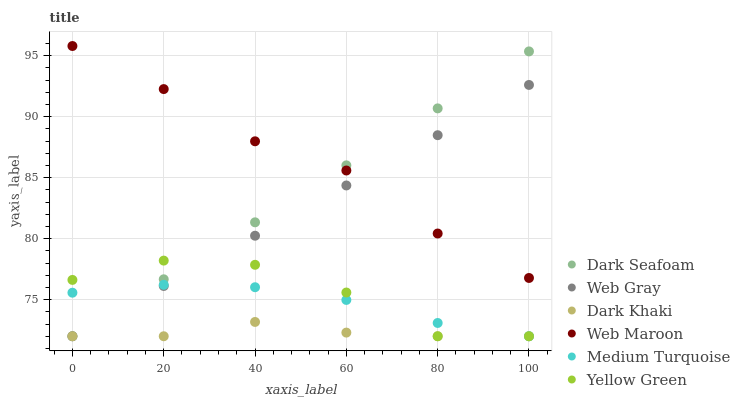Does Dark Khaki have the minimum area under the curve?
Answer yes or no. Yes. Does Web Maroon have the maximum area under the curve?
Answer yes or no. Yes. Does Yellow Green have the minimum area under the curve?
Answer yes or no. No. Does Yellow Green have the maximum area under the curve?
Answer yes or no. No. Is Dark Seafoam the smoothest?
Answer yes or no. Yes. Is Yellow Green the roughest?
Answer yes or no. Yes. Is Web Maroon the smoothest?
Answer yes or no. No. Is Web Maroon the roughest?
Answer yes or no. No. Does Web Gray have the lowest value?
Answer yes or no. Yes. Does Web Maroon have the lowest value?
Answer yes or no. No. Does Web Maroon have the highest value?
Answer yes or no. Yes. Does Yellow Green have the highest value?
Answer yes or no. No. Is Yellow Green less than Web Maroon?
Answer yes or no. Yes. Is Web Maroon greater than Dark Khaki?
Answer yes or no. Yes. Does Dark Seafoam intersect Medium Turquoise?
Answer yes or no. Yes. Is Dark Seafoam less than Medium Turquoise?
Answer yes or no. No. Is Dark Seafoam greater than Medium Turquoise?
Answer yes or no. No. Does Yellow Green intersect Web Maroon?
Answer yes or no. No. 